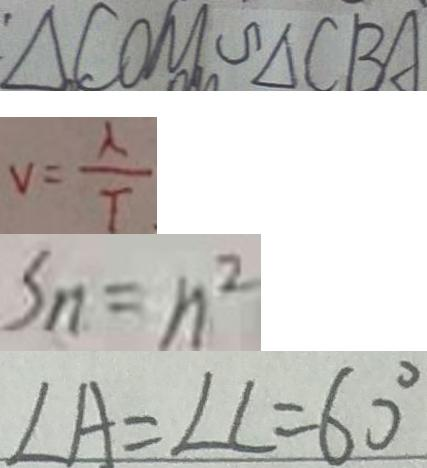Convert formula to latex. <formula><loc_0><loc_0><loc_500><loc_500>\Delta C O M \sim \Delta C B A 
 v = \frac { \lambda } { T } 
 S _ { n } = n ^ { 2 } 
 \angle A = \angle C = 6 0 ^ { \circ }</formula> 